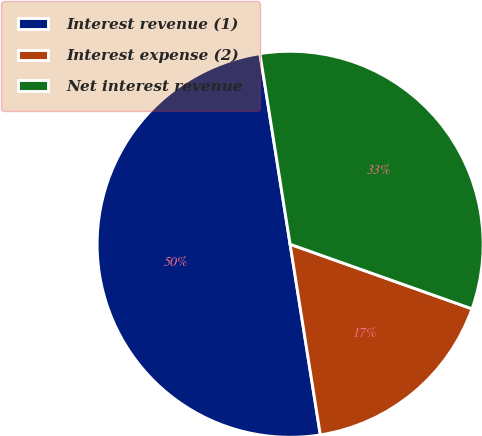Convert chart to OTSL. <chart><loc_0><loc_0><loc_500><loc_500><pie_chart><fcel>Interest revenue (1)<fcel>Interest expense (2)<fcel>Net interest revenue<nl><fcel>50.0%<fcel>17.07%<fcel>32.93%<nl></chart> 